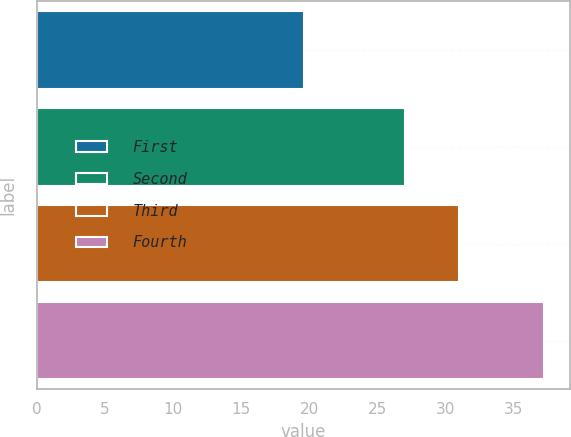<chart> <loc_0><loc_0><loc_500><loc_500><bar_chart><fcel>First<fcel>Second<fcel>Third<fcel>Fourth<nl><fcel>19.63<fcel>27<fcel>31<fcel>37.25<nl></chart> 